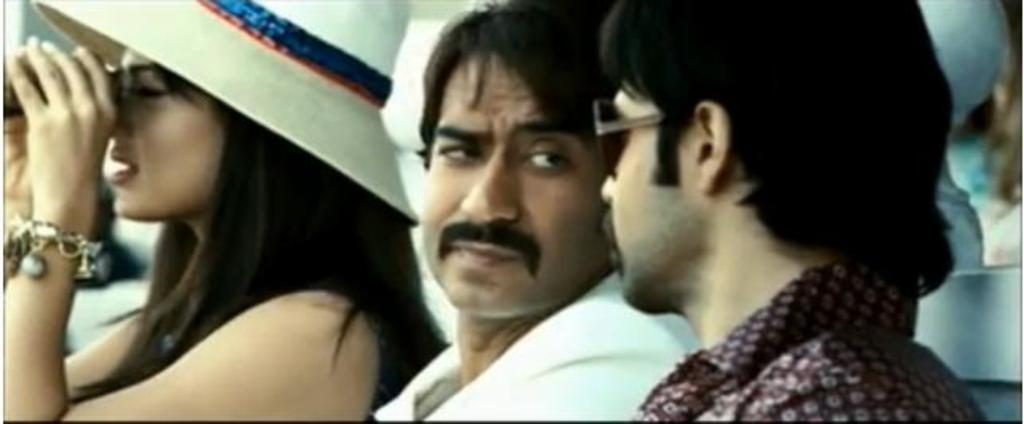How many people are present in the image? There are two men and one woman in the image. What are the men doing in the image? The men are sitting and looking at each other. What is the woman wearing in the image? The woman is wearing a white hat. What is the woman doing in the image? The woman is using binoculars. What rhythm is the woman tapping her foot to in the image? There is no mention of the woman tapping her foot or any rhythm in the image. 